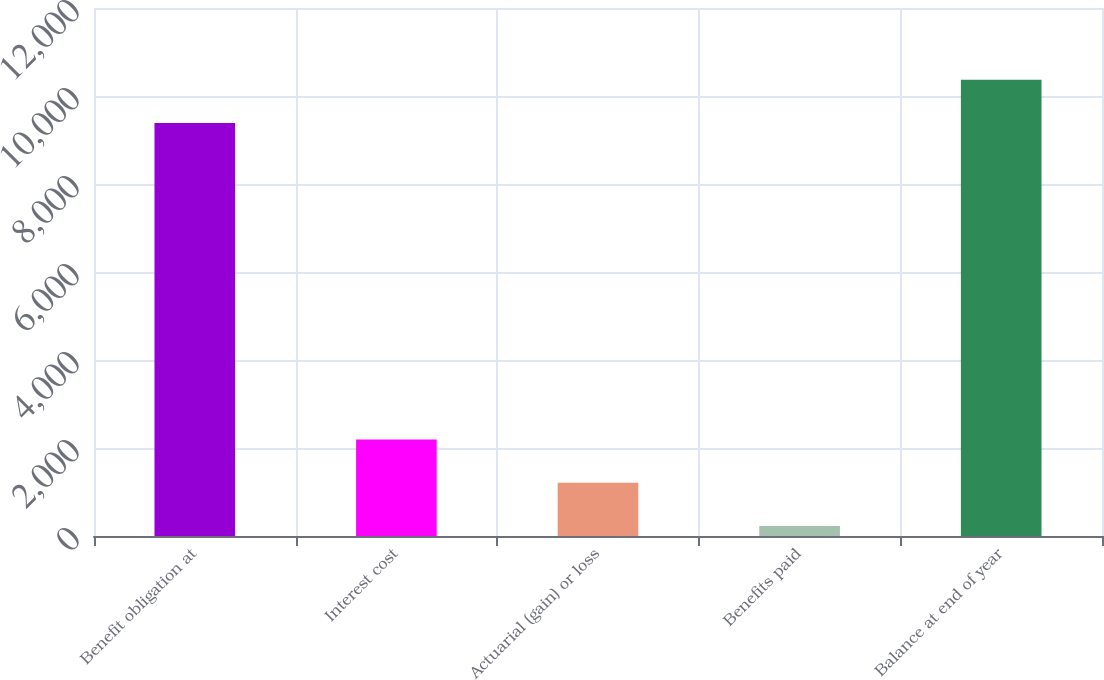Convert chart. <chart><loc_0><loc_0><loc_500><loc_500><bar_chart><fcel>Benefit obligation at<fcel>Interest cost<fcel>Actuarial (gain) or loss<fcel>Benefits paid<fcel>Balance at end of year<nl><fcel>9389<fcel>2194<fcel>1211<fcel>228<fcel>10372<nl></chart> 